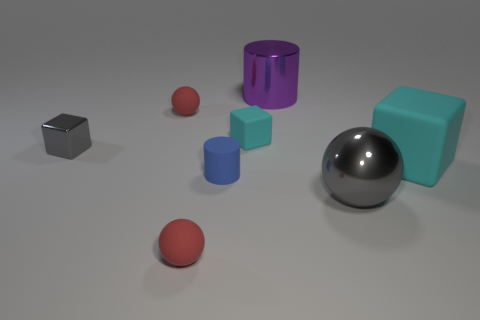Does the tiny metal thing have the same shape as the red matte object in front of the large matte thing? No, they do not share the same shape. The tiny metal thing appears to be a cube, whereas the red matte object in front of the large turquoise block is spherical. 